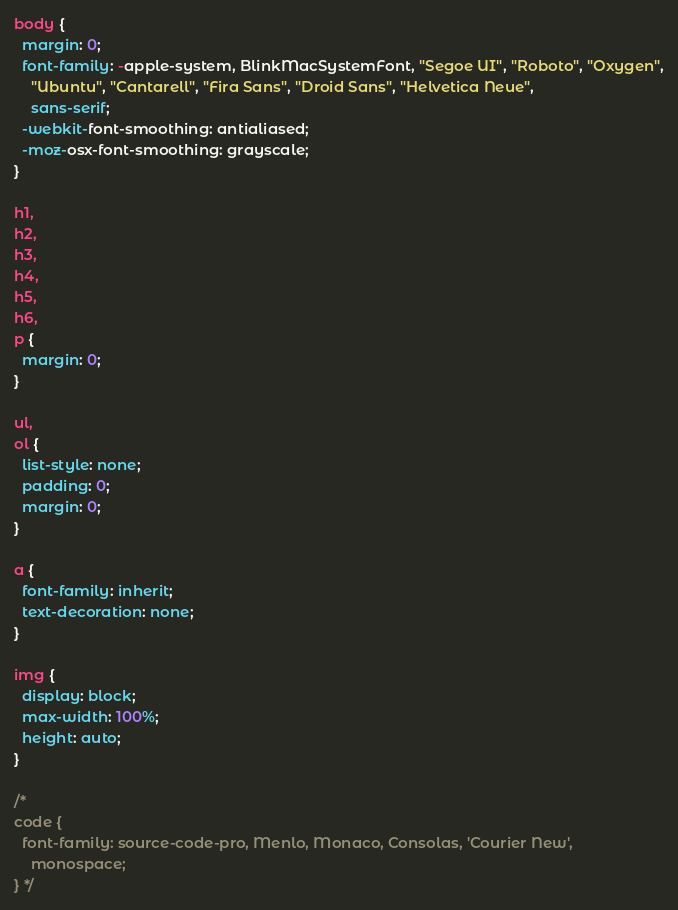<code> <loc_0><loc_0><loc_500><loc_500><_CSS_>
body {
  margin: 0;
  font-family: -apple-system, BlinkMacSystemFont, "Segoe UI", "Roboto", "Oxygen",
    "Ubuntu", "Cantarell", "Fira Sans", "Droid Sans", "Helvetica Neue",
    sans-serif;
  -webkit-font-smoothing: antialiased;
  -moz-osx-font-smoothing: grayscale;
}

h1,
h2,
h3,
h4,
h5,
h6,
p {
  margin: 0;
}

ul,
ol {
  list-style: none;
  padding: 0;
  margin: 0;
}

a {
  font-family: inherit;
  text-decoration: none;
}

img {
  display: block;
  max-width: 100%;
  height: auto;
}

/* 
code {
  font-family: source-code-pro, Menlo, Monaco, Consolas, 'Courier New',
    monospace;
} */
</code> 